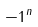Convert formula to latex. <formula><loc_0><loc_0><loc_500><loc_500>- 1 ^ { n }</formula> 